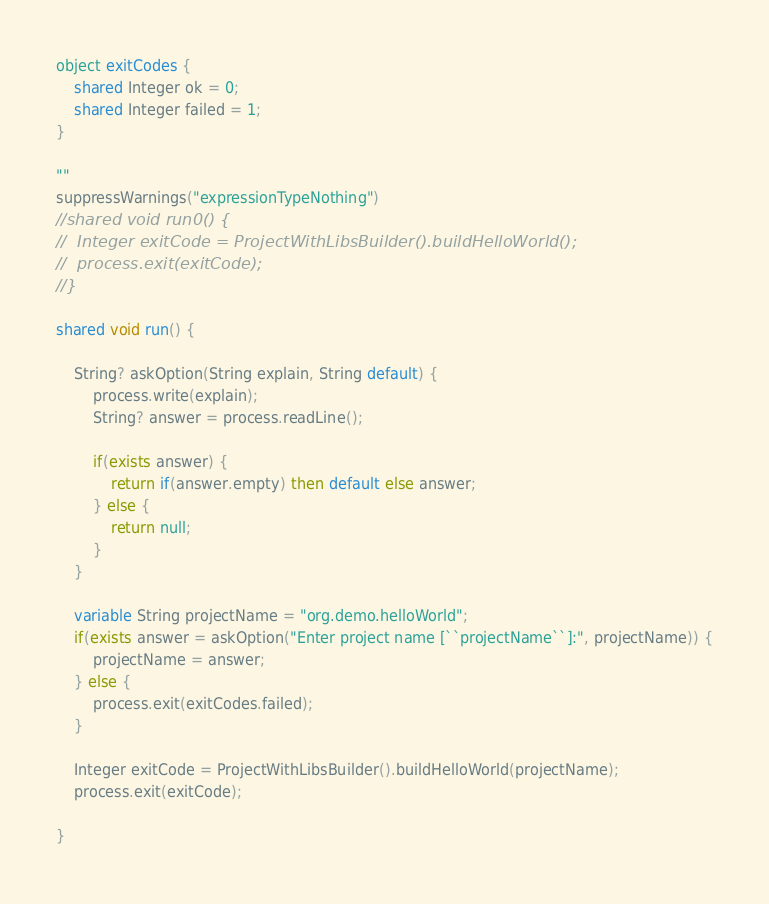Convert code to text. <code><loc_0><loc_0><loc_500><loc_500><_Ceylon_>

object exitCodes {
	shared Integer ok = 0;
	shared Integer failed = 1;
}

""
suppressWarnings("expressionTypeNothing")
//shared void run0() {
//	Integer exitCode = ProjectWithLibsBuilder().buildHelloWorld();
//	process.exit(exitCode);
//}

shared void run() {
	
	String? askOption(String explain, String default) {
		process.write(explain);
		String? answer = process.readLine();
		
		if(exists answer) {
			return if(answer.empty) then default else answer;
		} else {
			return null;
		}
	}
	
	variable String projectName = "org.demo.helloWorld";
	if(exists answer = askOption("Enter project name [``projectName``]:", projectName)) {
		projectName = answer;
	} else {
		process.exit(exitCodes.failed);
	}

	Integer exitCode = ProjectWithLibsBuilder().buildHelloWorld(projectName);
	process.exit(exitCode);
	
}




</code> 